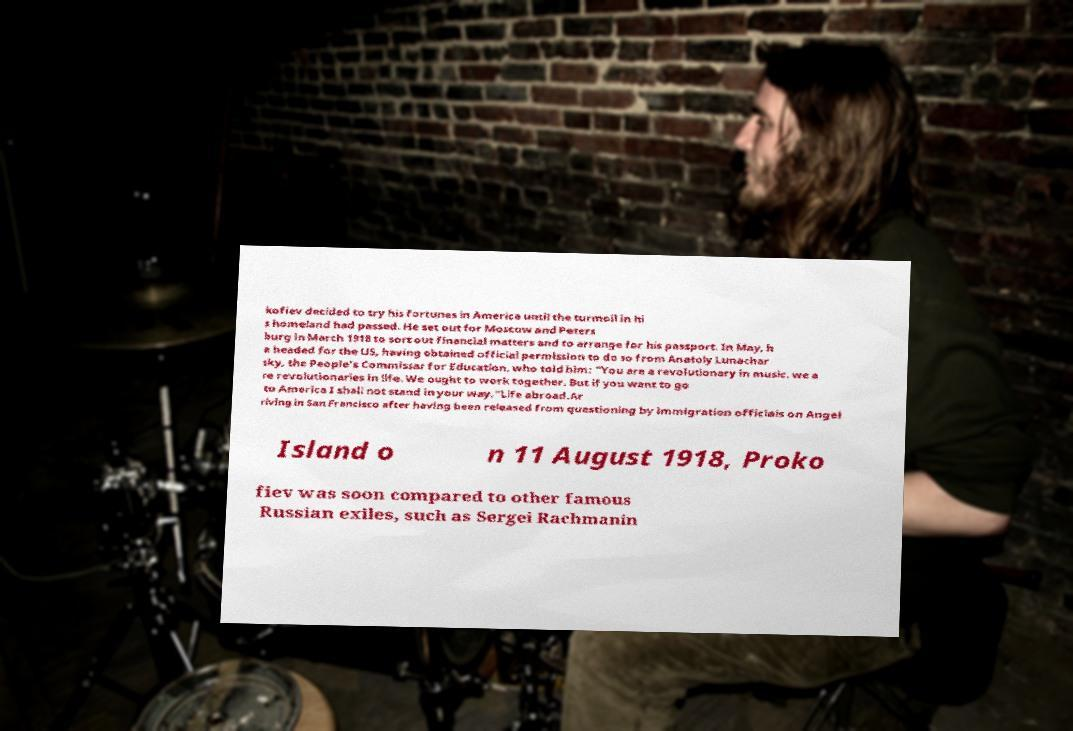I need the written content from this picture converted into text. Can you do that? kofiev decided to try his fortunes in America until the turmoil in hi s homeland had passed. He set out for Moscow and Peters burg in March 1918 to sort out financial matters and to arrange for his passport. In May, h e headed for the US, having obtained official permission to do so from Anatoly Lunachar sky, the People's Commissar for Education, who told him: "You are a revolutionary in music, we a re revolutionaries in life. We ought to work together. But if you want to go to America I shall not stand in your way."Life abroad.Ar riving in San Francisco after having been released from questioning by immigration officials on Angel Island o n 11 August 1918, Proko fiev was soon compared to other famous Russian exiles, such as Sergei Rachmanin 